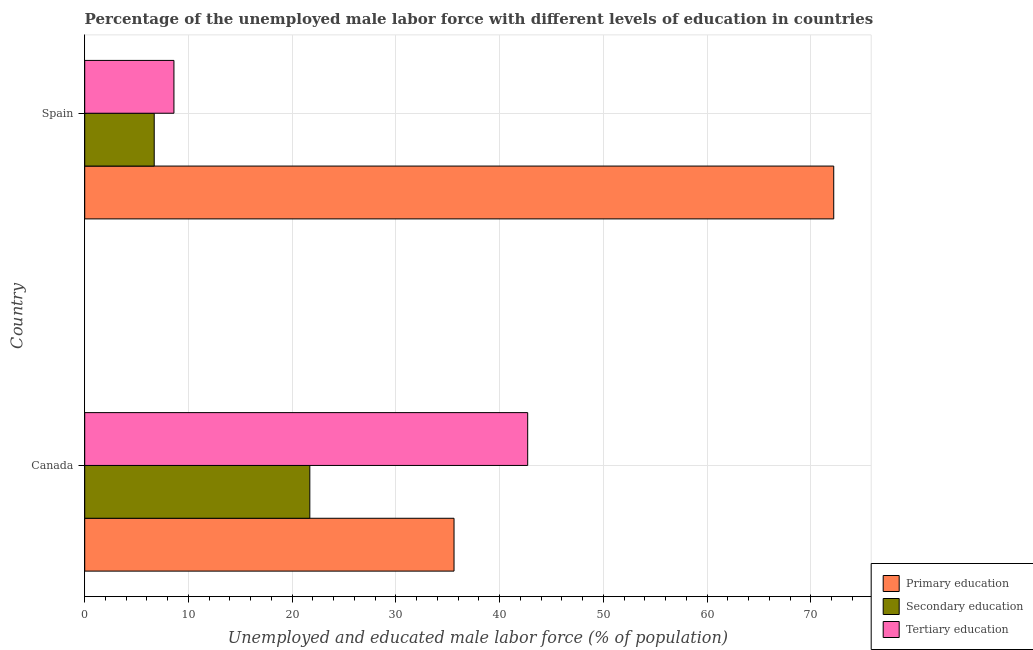How many different coloured bars are there?
Make the answer very short. 3. How many groups of bars are there?
Your answer should be compact. 2. Are the number of bars per tick equal to the number of legend labels?
Make the answer very short. Yes. How many bars are there on the 1st tick from the top?
Offer a very short reply. 3. How many bars are there on the 2nd tick from the bottom?
Ensure brevity in your answer.  3. What is the label of the 2nd group of bars from the top?
Make the answer very short. Canada. In how many cases, is the number of bars for a given country not equal to the number of legend labels?
Keep it short and to the point. 0. What is the percentage of male labor force who received tertiary education in Canada?
Your response must be concise. 42.7. Across all countries, what is the maximum percentage of male labor force who received secondary education?
Your answer should be very brief. 21.7. Across all countries, what is the minimum percentage of male labor force who received primary education?
Your answer should be compact. 35.6. In which country was the percentage of male labor force who received primary education maximum?
Your answer should be very brief. Spain. In which country was the percentage of male labor force who received tertiary education minimum?
Offer a very short reply. Spain. What is the total percentage of male labor force who received primary education in the graph?
Your answer should be very brief. 107.8. What is the difference between the percentage of male labor force who received primary education in Canada and that in Spain?
Your response must be concise. -36.6. What is the difference between the percentage of male labor force who received secondary education in Canada and the percentage of male labor force who received primary education in Spain?
Offer a terse response. -50.5. What is the average percentage of male labor force who received primary education per country?
Give a very brief answer. 53.9. What is the difference between the percentage of male labor force who received tertiary education and percentage of male labor force who received primary education in Spain?
Offer a very short reply. -63.6. In how many countries, is the percentage of male labor force who received tertiary education greater than 32 %?
Keep it short and to the point. 1. What is the ratio of the percentage of male labor force who received tertiary education in Canada to that in Spain?
Ensure brevity in your answer.  4.96. What does the 3rd bar from the top in Canada represents?
Provide a succinct answer. Primary education. What does the 2nd bar from the bottom in Canada represents?
Give a very brief answer. Secondary education. Is it the case that in every country, the sum of the percentage of male labor force who received primary education and percentage of male labor force who received secondary education is greater than the percentage of male labor force who received tertiary education?
Ensure brevity in your answer.  Yes. What is the difference between two consecutive major ticks on the X-axis?
Your answer should be very brief. 10. Does the graph contain any zero values?
Offer a terse response. No. Where does the legend appear in the graph?
Your answer should be compact. Bottom right. How many legend labels are there?
Offer a very short reply. 3. How are the legend labels stacked?
Your response must be concise. Vertical. What is the title of the graph?
Your answer should be compact. Percentage of the unemployed male labor force with different levels of education in countries. What is the label or title of the X-axis?
Your answer should be very brief. Unemployed and educated male labor force (% of population). What is the Unemployed and educated male labor force (% of population) of Primary education in Canada?
Provide a short and direct response. 35.6. What is the Unemployed and educated male labor force (% of population) of Secondary education in Canada?
Provide a short and direct response. 21.7. What is the Unemployed and educated male labor force (% of population) of Tertiary education in Canada?
Keep it short and to the point. 42.7. What is the Unemployed and educated male labor force (% of population) of Primary education in Spain?
Offer a very short reply. 72.2. What is the Unemployed and educated male labor force (% of population) of Secondary education in Spain?
Provide a succinct answer. 6.7. What is the Unemployed and educated male labor force (% of population) in Tertiary education in Spain?
Make the answer very short. 8.6. Across all countries, what is the maximum Unemployed and educated male labor force (% of population) in Primary education?
Provide a short and direct response. 72.2. Across all countries, what is the maximum Unemployed and educated male labor force (% of population) of Secondary education?
Ensure brevity in your answer.  21.7. Across all countries, what is the maximum Unemployed and educated male labor force (% of population) of Tertiary education?
Offer a terse response. 42.7. Across all countries, what is the minimum Unemployed and educated male labor force (% of population) in Primary education?
Provide a short and direct response. 35.6. Across all countries, what is the minimum Unemployed and educated male labor force (% of population) in Secondary education?
Make the answer very short. 6.7. Across all countries, what is the minimum Unemployed and educated male labor force (% of population) of Tertiary education?
Keep it short and to the point. 8.6. What is the total Unemployed and educated male labor force (% of population) in Primary education in the graph?
Your response must be concise. 107.8. What is the total Unemployed and educated male labor force (% of population) in Secondary education in the graph?
Give a very brief answer. 28.4. What is the total Unemployed and educated male labor force (% of population) in Tertiary education in the graph?
Keep it short and to the point. 51.3. What is the difference between the Unemployed and educated male labor force (% of population) in Primary education in Canada and that in Spain?
Keep it short and to the point. -36.6. What is the difference between the Unemployed and educated male labor force (% of population) in Tertiary education in Canada and that in Spain?
Keep it short and to the point. 34.1. What is the difference between the Unemployed and educated male labor force (% of population) of Primary education in Canada and the Unemployed and educated male labor force (% of population) of Secondary education in Spain?
Your answer should be very brief. 28.9. What is the difference between the Unemployed and educated male labor force (% of population) in Primary education in Canada and the Unemployed and educated male labor force (% of population) in Tertiary education in Spain?
Your answer should be compact. 27. What is the difference between the Unemployed and educated male labor force (% of population) in Secondary education in Canada and the Unemployed and educated male labor force (% of population) in Tertiary education in Spain?
Your response must be concise. 13.1. What is the average Unemployed and educated male labor force (% of population) of Primary education per country?
Keep it short and to the point. 53.9. What is the average Unemployed and educated male labor force (% of population) in Secondary education per country?
Your answer should be very brief. 14.2. What is the average Unemployed and educated male labor force (% of population) of Tertiary education per country?
Your answer should be compact. 25.65. What is the difference between the Unemployed and educated male labor force (% of population) in Primary education and Unemployed and educated male labor force (% of population) in Secondary education in Canada?
Your answer should be very brief. 13.9. What is the difference between the Unemployed and educated male labor force (% of population) in Primary education and Unemployed and educated male labor force (% of population) in Tertiary education in Canada?
Offer a very short reply. -7.1. What is the difference between the Unemployed and educated male labor force (% of population) of Primary education and Unemployed and educated male labor force (% of population) of Secondary education in Spain?
Provide a short and direct response. 65.5. What is the difference between the Unemployed and educated male labor force (% of population) of Primary education and Unemployed and educated male labor force (% of population) of Tertiary education in Spain?
Offer a terse response. 63.6. What is the difference between the Unemployed and educated male labor force (% of population) in Secondary education and Unemployed and educated male labor force (% of population) in Tertiary education in Spain?
Ensure brevity in your answer.  -1.9. What is the ratio of the Unemployed and educated male labor force (% of population) of Primary education in Canada to that in Spain?
Ensure brevity in your answer.  0.49. What is the ratio of the Unemployed and educated male labor force (% of population) in Secondary education in Canada to that in Spain?
Provide a succinct answer. 3.24. What is the ratio of the Unemployed and educated male labor force (% of population) of Tertiary education in Canada to that in Spain?
Provide a short and direct response. 4.97. What is the difference between the highest and the second highest Unemployed and educated male labor force (% of population) of Primary education?
Provide a succinct answer. 36.6. What is the difference between the highest and the second highest Unemployed and educated male labor force (% of population) of Tertiary education?
Keep it short and to the point. 34.1. What is the difference between the highest and the lowest Unemployed and educated male labor force (% of population) in Primary education?
Provide a short and direct response. 36.6. What is the difference between the highest and the lowest Unemployed and educated male labor force (% of population) in Tertiary education?
Your response must be concise. 34.1. 